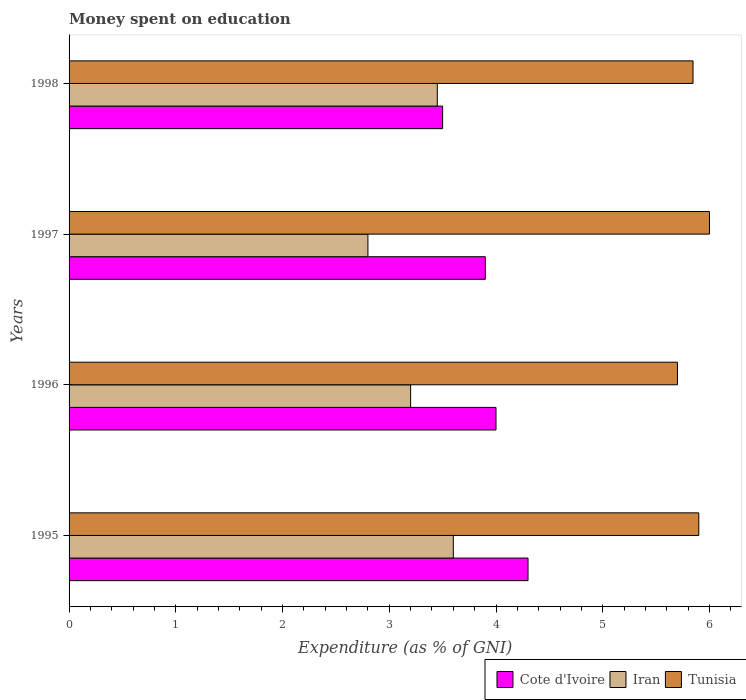How many different coloured bars are there?
Offer a terse response. 3. Are the number of bars on each tick of the Y-axis equal?
Offer a terse response. Yes. How many bars are there on the 1st tick from the bottom?
Ensure brevity in your answer.  3. What is the label of the 2nd group of bars from the top?
Offer a very short reply. 1997. Across all years, what is the minimum amount of money spent on education in Cote d'Ivoire?
Make the answer very short. 3.5. In which year was the amount of money spent on education in Iran maximum?
Offer a very short reply. 1995. What is the total amount of money spent on education in Cote d'Ivoire in the graph?
Ensure brevity in your answer.  15.7. What is the difference between the amount of money spent on education in Iran in 1995 and that in 1997?
Give a very brief answer. 0.8. What is the difference between the amount of money spent on education in Tunisia in 1996 and the amount of money spent on education in Iran in 1998?
Keep it short and to the point. 2.25. What is the average amount of money spent on education in Tunisia per year?
Ensure brevity in your answer.  5.86. In the year 1998, what is the difference between the amount of money spent on education in Iran and amount of money spent on education in Cote d'Ivoire?
Give a very brief answer. -0.05. What is the ratio of the amount of money spent on education in Cote d'Ivoire in 1995 to that in 1998?
Keep it short and to the point. 1.23. Is the difference between the amount of money spent on education in Iran in 1996 and 1997 greater than the difference between the amount of money spent on education in Cote d'Ivoire in 1996 and 1997?
Offer a terse response. Yes. What is the difference between the highest and the second highest amount of money spent on education in Tunisia?
Offer a very short reply. 0.1. What is the difference between the highest and the lowest amount of money spent on education in Cote d'Ivoire?
Your answer should be very brief. 0.8. In how many years, is the amount of money spent on education in Tunisia greater than the average amount of money spent on education in Tunisia taken over all years?
Offer a very short reply. 2. Is the sum of the amount of money spent on education in Cote d'Ivoire in 1995 and 1996 greater than the maximum amount of money spent on education in Tunisia across all years?
Your answer should be very brief. Yes. What does the 3rd bar from the top in 1997 represents?
Provide a succinct answer. Cote d'Ivoire. What does the 1st bar from the bottom in 1996 represents?
Offer a very short reply. Cote d'Ivoire. Is it the case that in every year, the sum of the amount of money spent on education in Iran and amount of money spent on education in Cote d'Ivoire is greater than the amount of money spent on education in Tunisia?
Provide a short and direct response. Yes. How many bars are there?
Keep it short and to the point. 12. Are all the bars in the graph horizontal?
Your answer should be compact. Yes. How many years are there in the graph?
Keep it short and to the point. 4. What is the difference between two consecutive major ticks on the X-axis?
Your answer should be compact. 1. Are the values on the major ticks of X-axis written in scientific E-notation?
Make the answer very short. No. Does the graph contain grids?
Keep it short and to the point. No. Where does the legend appear in the graph?
Give a very brief answer. Bottom right. How many legend labels are there?
Offer a very short reply. 3. How are the legend labels stacked?
Your response must be concise. Horizontal. What is the title of the graph?
Give a very brief answer. Money spent on education. Does "Sub-Saharan Africa (all income levels)" appear as one of the legend labels in the graph?
Ensure brevity in your answer.  No. What is the label or title of the X-axis?
Offer a terse response. Expenditure (as % of GNI). What is the Expenditure (as % of GNI) of Cote d'Ivoire in 1995?
Your answer should be compact. 4.3. What is the Expenditure (as % of GNI) in Cote d'Ivoire in 1996?
Provide a succinct answer. 4. What is the Expenditure (as % of GNI) of Iran in 1996?
Give a very brief answer. 3.2. What is the Expenditure (as % of GNI) of Cote d'Ivoire in 1997?
Your answer should be compact. 3.9. What is the Expenditure (as % of GNI) of Iran in 1997?
Your response must be concise. 2.8. What is the Expenditure (as % of GNI) in Cote d'Ivoire in 1998?
Make the answer very short. 3.5. What is the Expenditure (as % of GNI) of Iran in 1998?
Offer a terse response. 3.45. What is the Expenditure (as % of GNI) of Tunisia in 1998?
Offer a terse response. 5.85. Across all years, what is the maximum Expenditure (as % of GNI) in Iran?
Keep it short and to the point. 3.6. Across all years, what is the maximum Expenditure (as % of GNI) of Tunisia?
Offer a terse response. 6. Across all years, what is the minimum Expenditure (as % of GNI) of Cote d'Ivoire?
Provide a short and direct response. 3.5. Across all years, what is the minimum Expenditure (as % of GNI) in Iran?
Keep it short and to the point. 2.8. What is the total Expenditure (as % of GNI) in Cote d'Ivoire in the graph?
Your answer should be very brief. 15.7. What is the total Expenditure (as % of GNI) in Iran in the graph?
Keep it short and to the point. 13.05. What is the total Expenditure (as % of GNI) of Tunisia in the graph?
Provide a succinct answer. 23.45. What is the difference between the Expenditure (as % of GNI) in Cote d'Ivoire in 1995 and that in 1996?
Provide a short and direct response. 0.3. What is the difference between the Expenditure (as % of GNI) of Iran in 1995 and that in 1996?
Keep it short and to the point. 0.4. What is the difference between the Expenditure (as % of GNI) in Tunisia in 1995 and that in 1996?
Provide a short and direct response. 0.2. What is the difference between the Expenditure (as % of GNI) of Cote d'Ivoire in 1995 and that in 1997?
Provide a short and direct response. 0.4. What is the difference between the Expenditure (as % of GNI) of Tunisia in 1995 and that in 1997?
Your response must be concise. -0.1. What is the difference between the Expenditure (as % of GNI) in Cote d'Ivoire in 1995 and that in 1998?
Offer a terse response. 0.8. What is the difference between the Expenditure (as % of GNI) of Tunisia in 1995 and that in 1998?
Provide a short and direct response. 0.05. What is the difference between the Expenditure (as % of GNI) of Cote d'Ivoire in 1996 and that in 1998?
Give a very brief answer. 0.5. What is the difference between the Expenditure (as % of GNI) in Iran in 1996 and that in 1998?
Make the answer very short. -0.25. What is the difference between the Expenditure (as % of GNI) of Tunisia in 1996 and that in 1998?
Offer a very short reply. -0.15. What is the difference between the Expenditure (as % of GNI) in Iran in 1997 and that in 1998?
Give a very brief answer. -0.65. What is the difference between the Expenditure (as % of GNI) of Tunisia in 1997 and that in 1998?
Provide a succinct answer. 0.15. What is the difference between the Expenditure (as % of GNI) in Cote d'Ivoire in 1995 and the Expenditure (as % of GNI) in Iran in 1996?
Offer a very short reply. 1.1. What is the difference between the Expenditure (as % of GNI) of Cote d'Ivoire in 1995 and the Expenditure (as % of GNI) of Tunisia in 1996?
Offer a terse response. -1.4. What is the difference between the Expenditure (as % of GNI) in Iran in 1995 and the Expenditure (as % of GNI) in Tunisia in 1996?
Your answer should be very brief. -2.1. What is the difference between the Expenditure (as % of GNI) of Cote d'Ivoire in 1995 and the Expenditure (as % of GNI) of Tunisia in 1997?
Keep it short and to the point. -1.7. What is the difference between the Expenditure (as % of GNI) of Cote d'Ivoire in 1995 and the Expenditure (as % of GNI) of Iran in 1998?
Your response must be concise. 0.85. What is the difference between the Expenditure (as % of GNI) in Cote d'Ivoire in 1995 and the Expenditure (as % of GNI) in Tunisia in 1998?
Provide a short and direct response. -1.55. What is the difference between the Expenditure (as % of GNI) of Iran in 1995 and the Expenditure (as % of GNI) of Tunisia in 1998?
Provide a short and direct response. -2.25. What is the difference between the Expenditure (as % of GNI) of Cote d'Ivoire in 1996 and the Expenditure (as % of GNI) of Iran in 1997?
Keep it short and to the point. 1.2. What is the difference between the Expenditure (as % of GNI) in Cote d'Ivoire in 1996 and the Expenditure (as % of GNI) in Tunisia in 1997?
Provide a short and direct response. -2. What is the difference between the Expenditure (as % of GNI) in Cote d'Ivoire in 1996 and the Expenditure (as % of GNI) in Iran in 1998?
Provide a succinct answer. 0.55. What is the difference between the Expenditure (as % of GNI) of Cote d'Ivoire in 1996 and the Expenditure (as % of GNI) of Tunisia in 1998?
Offer a very short reply. -1.85. What is the difference between the Expenditure (as % of GNI) in Iran in 1996 and the Expenditure (as % of GNI) in Tunisia in 1998?
Offer a terse response. -2.65. What is the difference between the Expenditure (as % of GNI) of Cote d'Ivoire in 1997 and the Expenditure (as % of GNI) of Iran in 1998?
Make the answer very short. 0.45. What is the difference between the Expenditure (as % of GNI) of Cote d'Ivoire in 1997 and the Expenditure (as % of GNI) of Tunisia in 1998?
Provide a succinct answer. -1.95. What is the difference between the Expenditure (as % of GNI) in Iran in 1997 and the Expenditure (as % of GNI) in Tunisia in 1998?
Ensure brevity in your answer.  -3.05. What is the average Expenditure (as % of GNI) in Cote d'Ivoire per year?
Offer a terse response. 3.92. What is the average Expenditure (as % of GNI) of Iran per year?
Your response must be concise. 3.26. What is the average Expenditure (as % of GNI) in Tunisia per year?
Your response must be concise. 5.86. In the year 1995, what is the difference between the Expenditure (as % of GNI) of Cote d'Ivoire and Expenditure (as % of GNI) of Iran?
Offer a terse response. 0.7. In the year 1995, what is the difference between the Expenditure (as % of GNI) of Iran and Expenditure (as % of GNI) of Tunisia?
Provide a short and direct response. -2.3. In the year 1996, what is the difference between the Expenditure (as % of GNI) of Cote d'Ivoire and Expenditure (as % of GNI) of Tunisia?
Keep it short and to the point. -1.7. In the year 1996, what is the difference between the Expenditure (as % of GNI) of Iran and Expenditure (as % of GNI) of Tunisia?
Keep it short and to the point. -2.5. In the year 1997, what is the difference between the Expenditure (as % of GNI) of Cote d'Ivoire and Expenditure (as % of GNI) of Iran?
Provide a succinct answer. 1.1. In the year 1997, what is the difference between the Expenditure (as % of GNI) in Iran and Expenditure (as % of GNI) in Tunisia?
Give a very brief answer. -3.2. In the year 1998, what is the difference between the Expenditure (as % of GNI) in Cote d'Ivoire and Expenditure (as % of GNI) in Tunisia?
Your answer should be very brief. -2.35. In the year 1998, what is the difference between the Expenditure (as % of GNI) of Iran and Expenditure (as % of GNI) of Tunisia?
Keep it short and to the point. -2.4. What is the ratio of the Expenditure (as % of GNI) of Cote d'Ivoire in 1995 to that in 1996?
Give a very brief answer. 1.07. What is the ratio of the Expenditure (as % of GNI) of Tunisia in 1995 to that in 1996?
Ensure brevity in your answer.  1.04. What is the ratio of the Expenditure (as % of GNI) in Cote d'Ivoire in 1995 to that in 1997?
Provide a succinct answer. 1.1. What is the ratio of the Expenditure (as % of GNI) in Iran in 1995 to that in 1997?
Give a very brief answer. 1.29. What is the ratio of the Expenditure (as % of GNI) in Tunisia in 1995 to that in 1997?
Provide a succinct answer. 0.98. What is the ratio of the Expenditure (as % of GNI) of Cote d'Ivoire in 1995 to that in 1998?
Offer a terse response. 1.23. What is the ratio of the Expenditure (as % of GNI) in Iran in 1995 to that in 1998?
Provide a succinct answer. 1.04. What is the ratio of the Expenditure (as % of GNI) of Tunisia in 1995 to that in 1998?
Provide a short and direct response. 1.01. What is the ratio of the Expenditure (as % of GNI) of Cote d'Ivoire in 1996 to that in 1997?
Provide a short and direct response. 1.03. What is the ratio of the Expenditure (as % of GNI) of Iran in 1996 to that in 1997?
Your answer should be very brief. 1.14. What is the ratio of the Expenditure (as % of GNI) of Cote d'Ivoire in 1996 to that in 1998?
Offer a terse response. 1.14. What is the ratio of the Expenditure (as % of GNI) of Iran in 1996 to that in 1998?
Offer a very short reply. 0.93. What is the ratio of the Expenditure (as % of GNI) in Tunisia in 1996 to that in 1998?
Your answer should be compact. 0.98. What is the ratio of the Expenditure (as % of GNI) in Cote d'Ivoire in 1997 to that in 1998?
Offer a very short reply. 1.11. What is the ratio of the Expenditure (as % of GNI) in Iran in 1997 to that in 1998?
Provide a short and direct response. 0.81. What is the ratio of the Expenditure (as % of GNI) in Tunisia in 1997 to that in 1998?
Your response must be concise. 1.03. What is the difference between the highest and the second highest Expenditure (as % of GNI) in Cote d'Ivoire?
Ensure brevity in your answer.  0.3. What is the difference between the highest and the second highest Expenditure (as % of GNI) of Iran?
Give a very brief answer. 0.15. What is the difference between the highest and the second highest Expenditure (as % of GNI) in Tunisia?
Keep it short and to the point. 0.1. What is the difference between the highest and the lowest Expenditure (as % of GNI) in Iran?
Your answer should be compact. 0.8. 